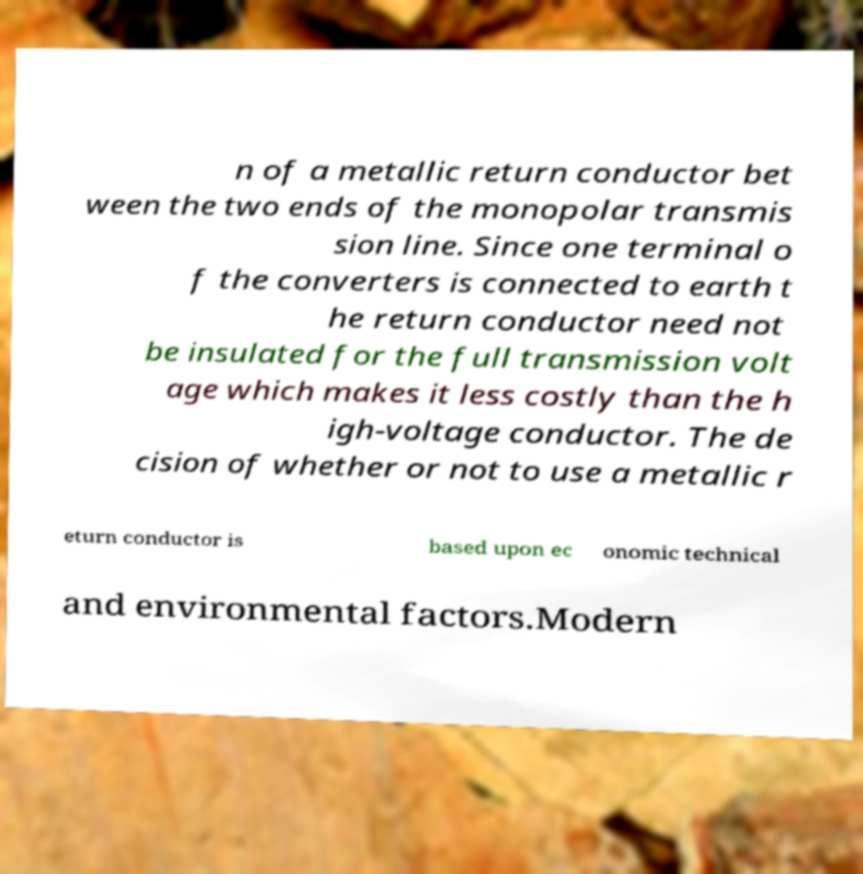Could you assist in decoding the text presented in this image and type it out clearly? n of a metallic return conductor bet ween the two ends of the monopolar transmis sion line. Since one terminal o f the converters is connected to earth t he return conductor need not be insulated for the full transmission volt age which makes it less costly than the h igh-voltage conductor. The de cision of whether or not to use a metallic r eturn conductor is based upon ec onomic technical and environmental factors.Modern 